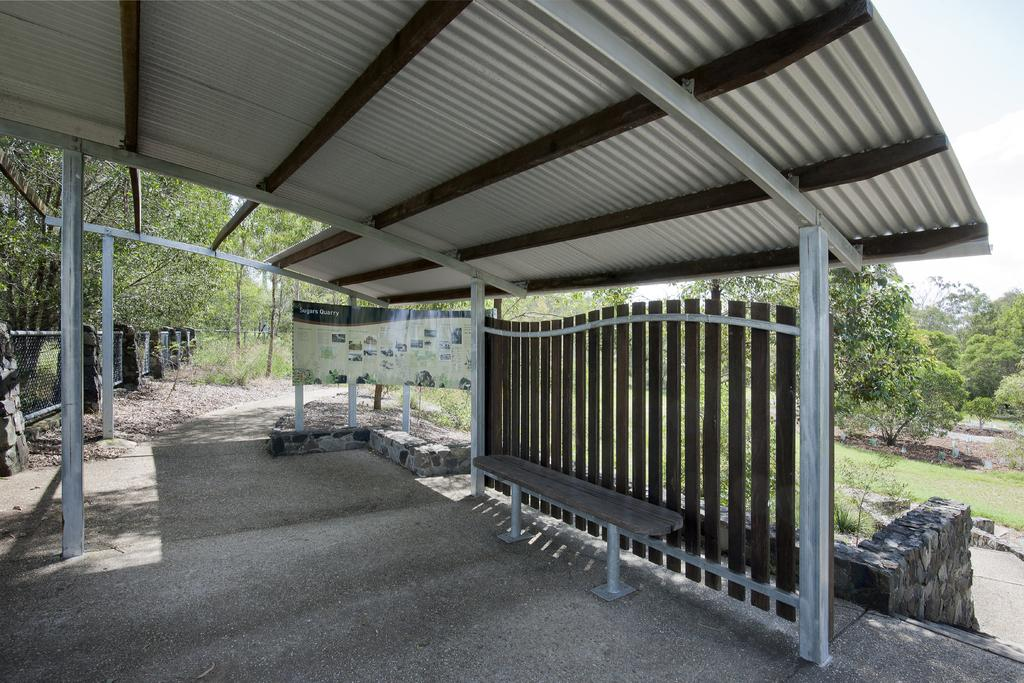What type of seating is present in the image? There is a bench on the ground in the image. What structure provides shelter in the image? There is a shelter in the image. What type of barrier is present in the image? There are fences in the image. What type of material is present in the image? There are boards in the image. What type of vegetation is present in the image? There are plants and trees in the image. What type of architectural feature is present in the image? There is a wall in the image. What else can be seen in the image? There are some objects in the image. What is visible in the background of the image? The sky is visible in the background of the image. What type of grain is being harvested in the image? There is no grain present in the image. What country is the image taken in? The image does not provide any information about the country it was taken in. 